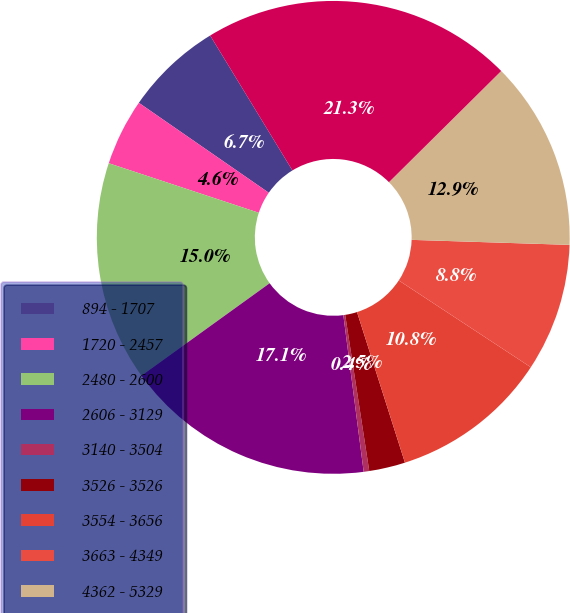Convert chart. <chart><loc_0><loc_0><loc_500><loc_500><pie_chart><fcel>894 - 1707<fcel>1720 - 2457<fcel>2480 - 2600<fcel>2606 - 3129<fcel>3140 - 3504<fcel>3526 - 3526<fcel>3554 - 3656<fcel>3663 - 4349<fcel>4362 - 5329<fcel>894 - 5330<nl><fcel>6.65%<fcel>4.56%<fcel>15.02%<fcel>17.11%<fcel>0.38%<fcel>2.47%<fcel>10.84%<fcel>8.75%<fcel>12.93%<fcel>21.29%<nl></chart> 